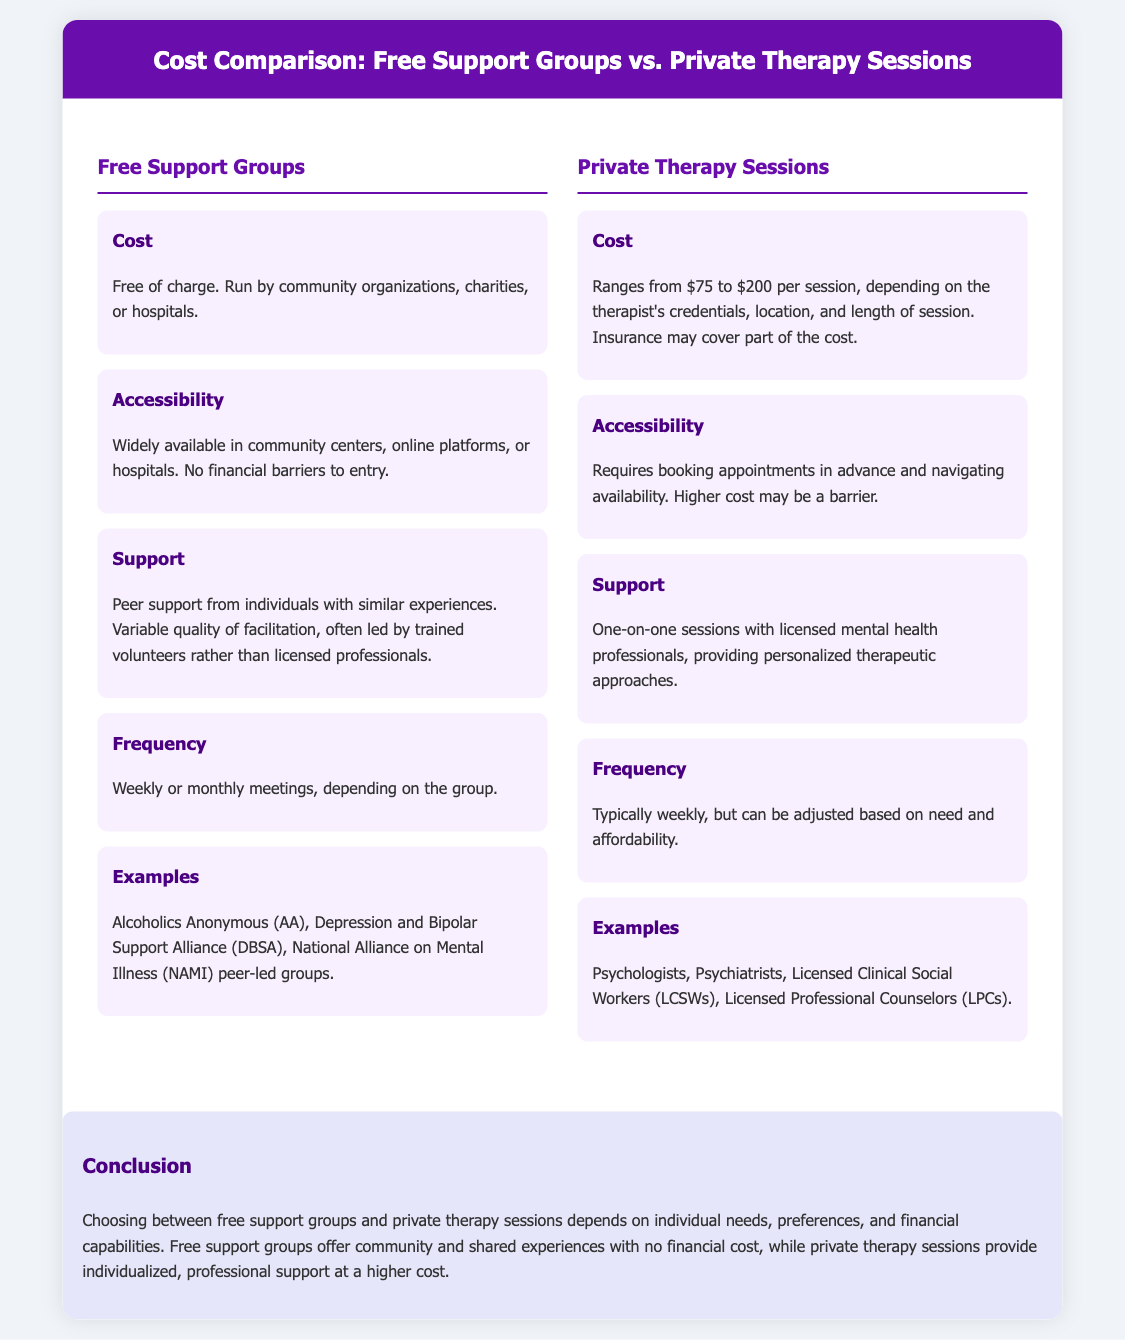what is the cost of free support groups? The cost of free support groups is described in the document as being free of charge.
Answer: free of charge what is the range of costs for private therapy sessions? The document lists the cost for private therapy sessions as ranging from $75 to $200 per session.
Answer: $75 to $200 how frequently do free support groups meet? According to the document, free support groups typically meet weekly or monthly.
Answer: weekly or monthly who provides support in private therapy sessions? The document states that support in private therapy sessions is provided by licensed mental health professionals.
Answer: licensed mental health professionals what is a common example of a free support group? The document mentions Alcoholics Anonymous (AA) as a common example of a free support group.
Answer: Alcoholics Anonymous (AA) what type of professionals conduct private therapy sessions? The document lists psychologists, psychiatrists, and licensed professional counselors as types of professionals.
Answer: psychologists, psychiatrists, and licensed professional counselors why might someone choose private therapy over free support groups? The conclusion indicates that private therapy provides individualized, professional support compared to peer support in free groups.
Answer: individualized, professional support what is a disadvantage of private therapy sessions mentioned in the document? The document notes that the higher cost of private therapy may be a barrier for some individuals.
Answer: higher cost may be a barrier what type of support do free support groups provide? Free support groups provide peer support from individuals with similar experiences.
Answer: peer support 